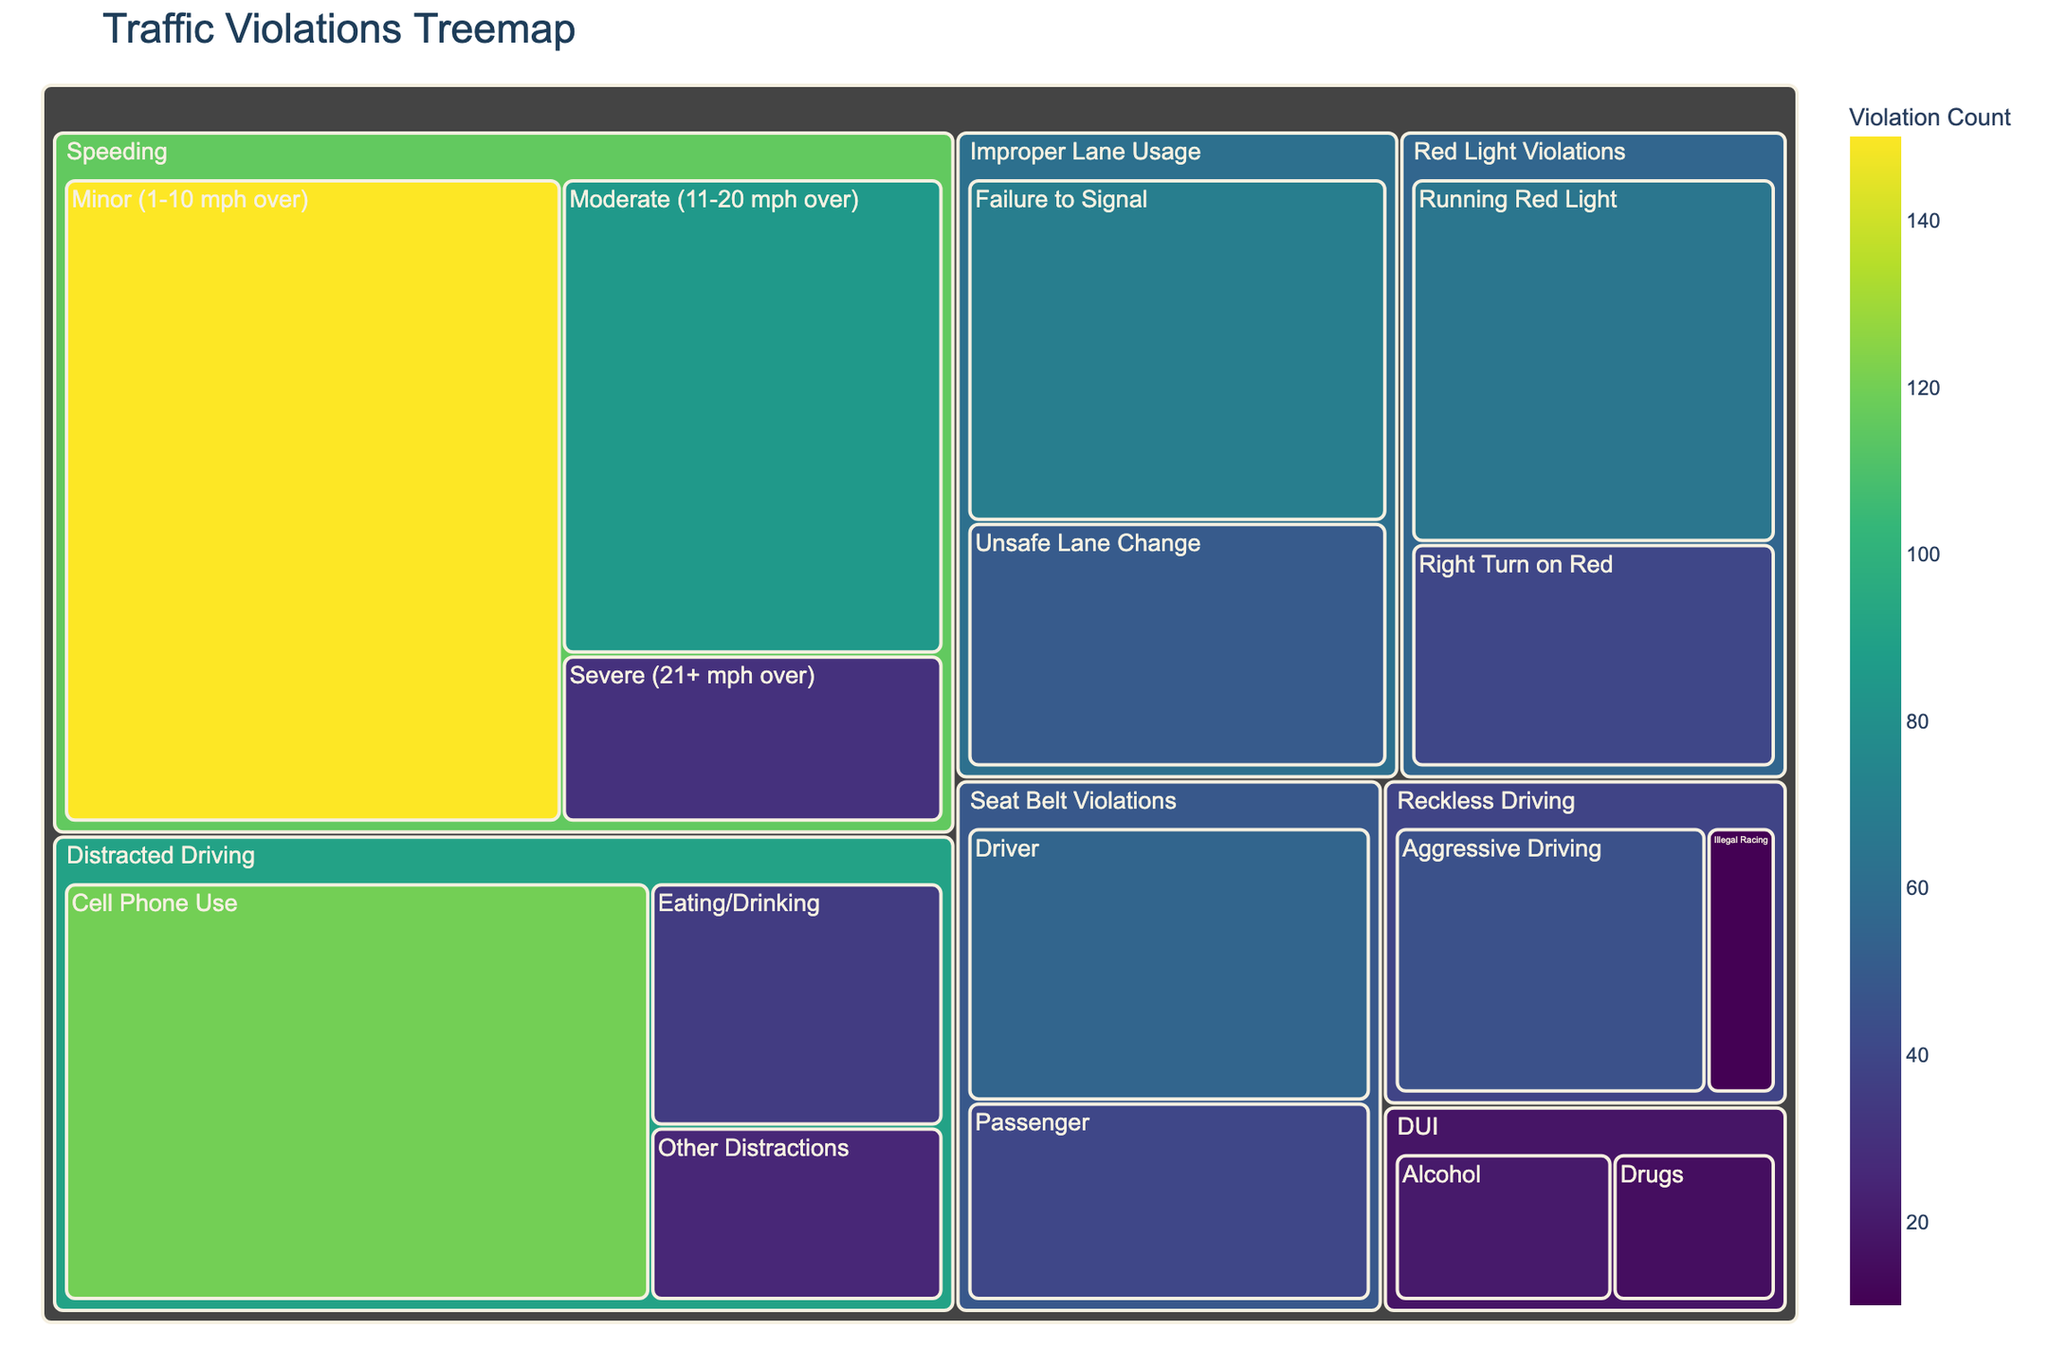What's the title of the figure? The title is usually displayed at the top of the figure and provides a summary of what the figure represents. In this case, it's specified in the code as 'Traffic Violations Treemap'.
Answer: Traffic Violations Treemap What color scale is used for visualizing the values in the treemap? The color scale helps in identifying different ranges of data. According to the code, the 'Viridis' color scale is used.
Answer: Viridis How many data points represent 'Seat Belt Violations'? In the Treemap, 'Seat Belt Violations' would typically have two subcategories: 'Driver' and 'Passenger'. Adding these values together gives 55 + 40.
Answer: 95 Which subcategory has the highest number of violations? By examining the values associated with each subcategory, the one with the highest number is 'Minor (1-10 mph over)' under 'Speeding' with 150 violations.
Answer: Minor (1-10 mph over) Compare the number of 'Distracted Driving' violations. Which type has the highest count? 'Distracted Driving' has three subcategories: 'Cell Phone Use', 'Eating/Drinking', and 'Other Distractions'. Among them, 'Cell Phone Use' has the highest count with 120 violations.
Answer: Cell Phone Use What is the sum of violations in the 'DUI' category? 'DUI' has two subcategories: 'Alcohol' and 'Drugs'. Adding these gives 20 + 15.
Answer: 35 Which has more violations: 'Speeding, Severe (21+ mph over)' or 'Red Light Violations, Running Red Light'? 'Speeding, Severe (21+ mph over)' has 30 violations, while 'Red Light Violations, Running Red Light' has 65 violations. Comparing these two, the latter has more.
Answer: Red Light Violations, Running Red Light What is the difference between 'Improper Lane Usage, Unsafe Lane Change' and 'Reckless Driving, Aggressive Driving' in terms of violations? 'Improper Lane Usage, Unsafe Lane Change' has 50 violations, while 'Reckless Driving, Aggressive Driving' has 45 violations. Subtracting these values gives 50 - 45.
Answer: 5 How many more violations are there for 'Improper Lane Usage, Failure to Signal' compared to 'Red Light Violations, Right Turn on Red'? 'Improper Lane Usage, Failure to Signal' has 70 violations; 'Red Light Violations, Right Turn on Red' has 40 violations. Subtracting these gives 70 - 40.
Answer: 30 